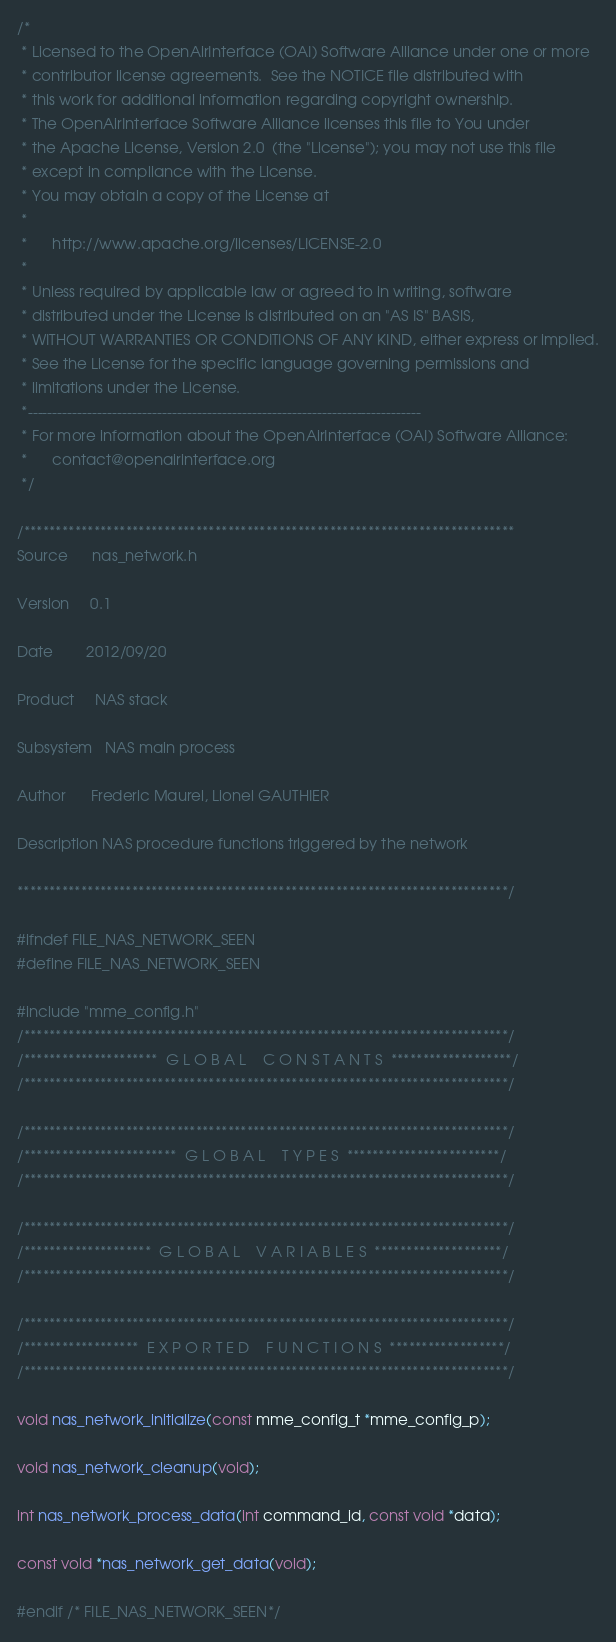<code> <loc_0><loc_0><loc_500><loc_500><_C_>/*
 * Licensed to the OpenAirInterface (OAI) Software Alliance under one or more
 * contributor license agreements.  See the NOTICE file distributed with
 * this work for additional information regarding copyright ownership.
 * The OpenAirInterface Software Alliance licenses this file to You under
 * the Apache License, Version 2.0  (the "License"); you may not use this file
 * except in compliance with the License.
 * You may obtain a copy of the License at
 *
 *      http://www.apache.org/licenses/LICENSE-2.0
 *
 * Unless required by applicable law or agreed to in writing, software
 * distributed under the License is distributed on an "AS IS" BASIS,
 * WITHOUT WARRANTIES OR CONDITIONS OF ANY KIND, either express or implied.
 * See the License for the specific language governing permissions and
 * limitations under the License.
 *-------------------------------------------------------------------------------
 * For more information about the OpenAirInterface (OAI) Software Alliance:
 *      contact@openairinterface.org
 */

/*****************************************************************************
Source      nas_network.h

Version     0.1

Date        2012/09/20

Product     NAS stack

Subsystem   NAS main process

Author      Frederic Maurel, Lionel GAUTHIER

Description NAS procedure functions triggered by the network

*****************************************************************************/

#ifndef FILE_NAS_NETWORK_SEEN
#define FILE_NAS_NETWORK_SEEN

#include "mme_config.h"
/****************************************************************************/
/*********************  G L O B A L    C O N S T A N T S  *******************/
/****************************************************************************/

/****************************************************************************/
/************************  G L O B A L    T Y P E S  ************************/
/****************************************************************************/

/****************************************************************************/
/********************  G L O B A L    V A R I A B L E S  ********************/
/****************************************************************************/

/****************************************************************************/
/******************  E X P O R T E D    F U N C T I O N S  ******************/
/****************************************************************************/

void nas_network_initialize(const mme_config_t *mme_config_p);

void nas_network_cleanup(void);

int nas_network_process_data(int command_id, const void *data);

const void *nas_network_get_data(void);

#endif /* FILE_NAS_NETWORK_SEEN*/
</code> 